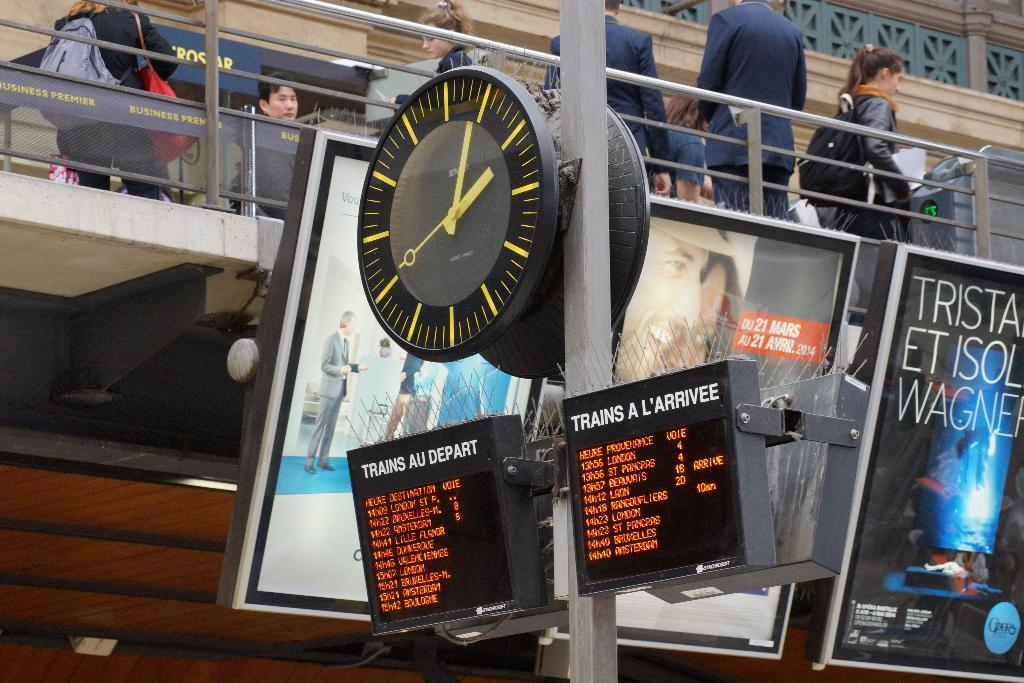<image>
Write a terse but informative summary of the picture. clock on pole in train station with screens showing times of trains departing and arriving 